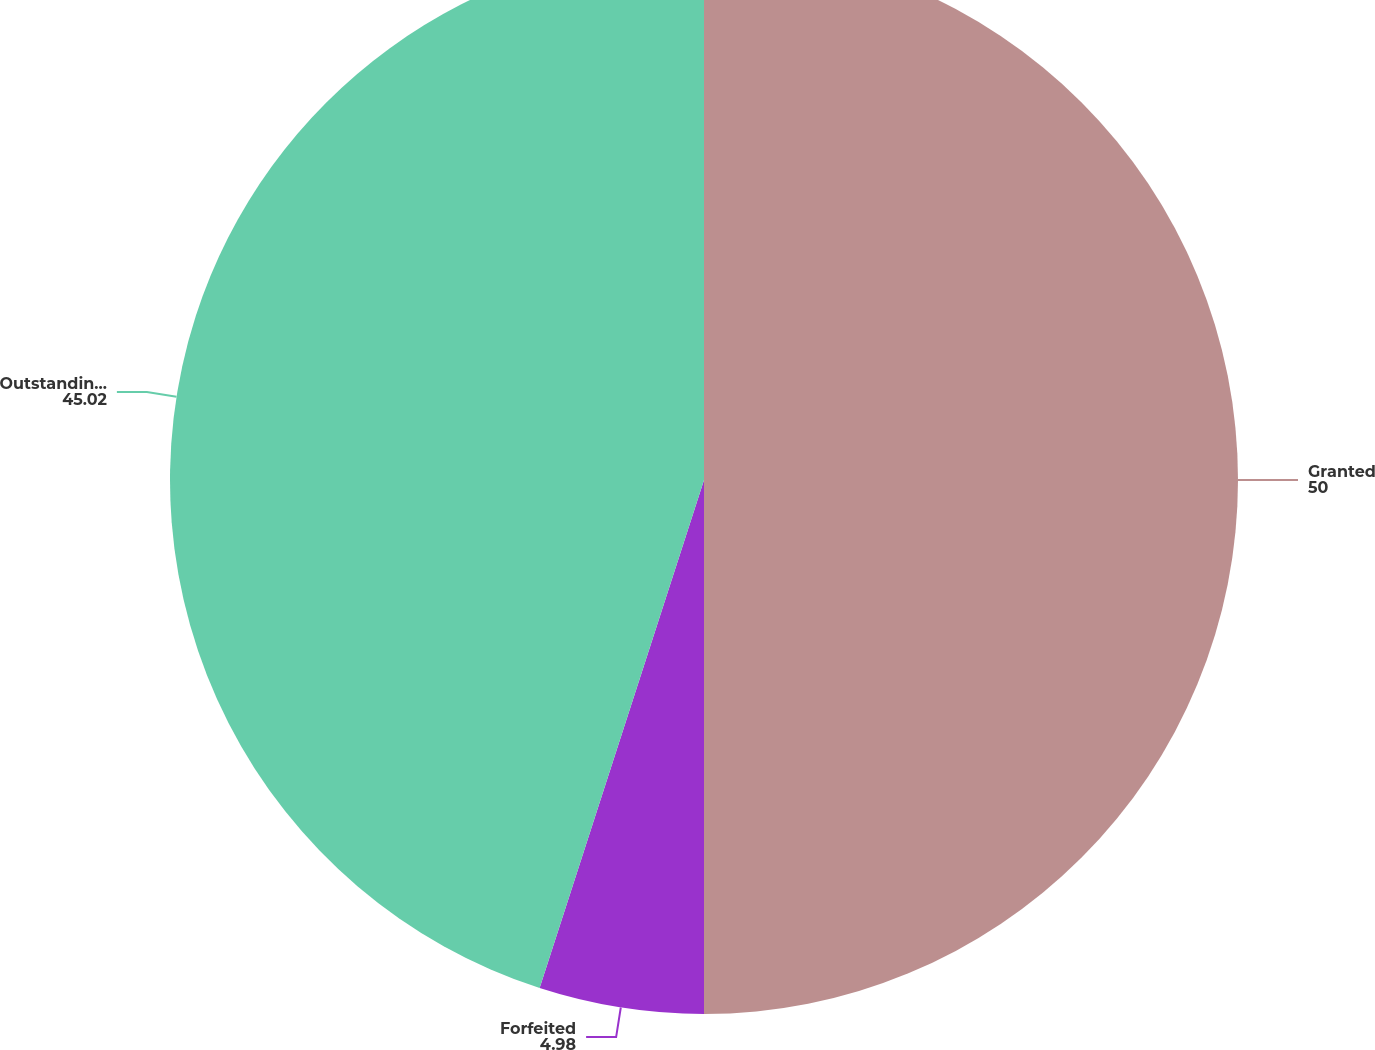<chart> <loc_0><loc_0><loc_500><loc_500><pie_chart><fcel>Granted<fcel>Forfeited<fcel>Outstanding at December 31<nl><fcel>50.0%<fcel>4.98%<fcel>45.02%<nl></chart> 